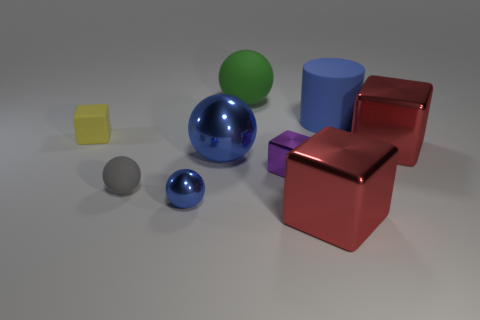What number of large things are either green spheres or cyan shiny objects?
Keep it short and to the point. 1. There is another tiny object that is the same shape as the small gray rubber object; what is its color?
Offer a very short reply. Blue. Do the rubber cube and the blue rubber thing have the same size?
Offer a very short reply. No. How many things are either small yellow shiny cylinders or red metallic cubes that are on the left side of the blue matte object?
Give a very brief answer. 1. There is a tiny matte thing behind the tiny metallic thing that is to the right of the big green ball; what color is it?
Your response must be concise. Yellow. Do the matte object that is on the right side of the purple metal thing and the big metal sphere have the same color?
Your answer should be compact. Yes. What is the large red thing that is right of the matte cylinder made of?
Offer a terse response. Metal. What is the size of the green matte object?
Ensure brevity in your answer.  Large. Is the material of the big sphere that is behind the big blue metal object the same as the tiny blue object?
Keep it short and to the point. No. How many blue things are there?
Make the answer very short. 3. 